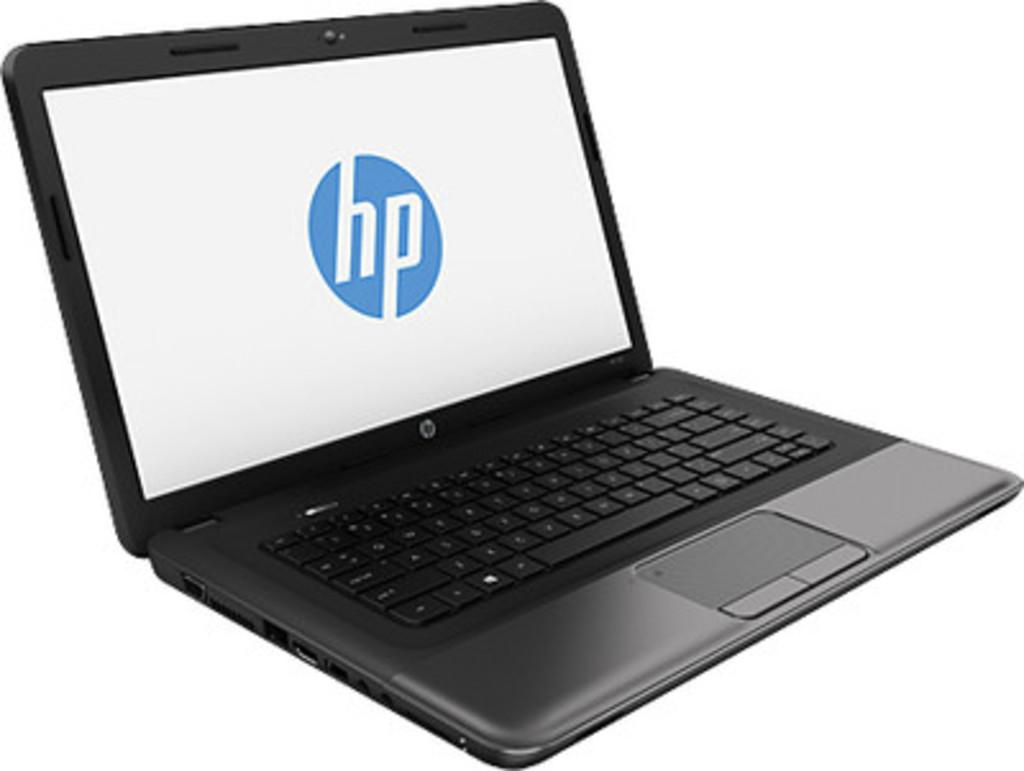<image>
Write a terse but informative summary of the picture. A laptop that has the HP logo on the screen 